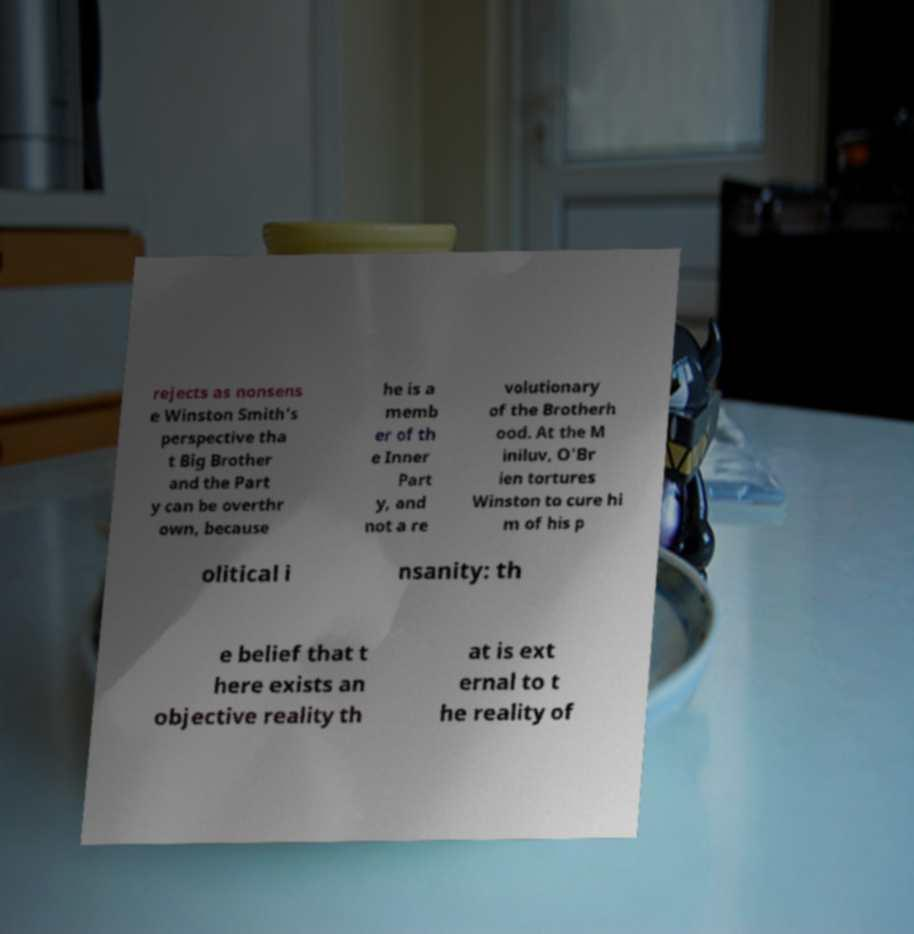Can you accurately transcribe the text from the provided image for me? rejects as nonsens e Winston Smith's perspective tha t Big Brother and the Part y can be overthr own, because he is a memb er of th e Inner Part y, and not a re volutionary of the Brotherh ood. At the M iniluv, O'Br ien tortures Winston to cure hi m of his p olitical i nsanity: th e belief that t here exists an objective reality th at is ext ernal to t he reality of 